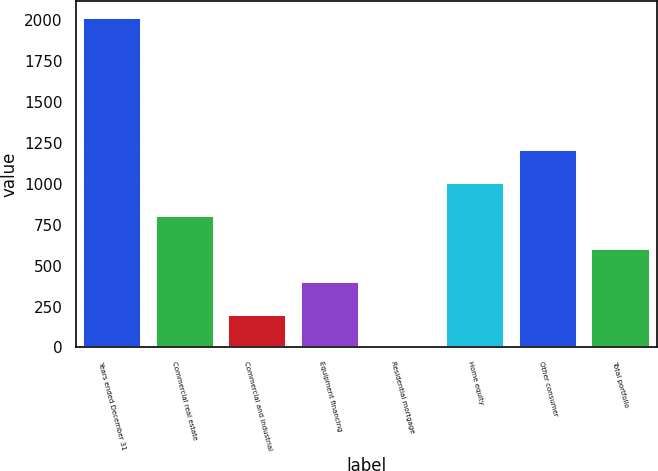Convert chart to OTSL. <chart><loc_0><loc_0><loc_500><loc_500><bar_chart><fcel>Years ended December 31<fcel>Commercial real estate<fcel>Commercial and industrial<fcel>Equipment financing<fcel>Residential mortgage<fcel>Home equity<fcel>Other consumer<fcel>Total portfolio<nl><fcel>2012<fcel>804.89<fcel>201.35<fcel>402.53<fcel>0.17<fcel>1006.07<fcel>1207.25<fcel>603.71<nl></chart> 